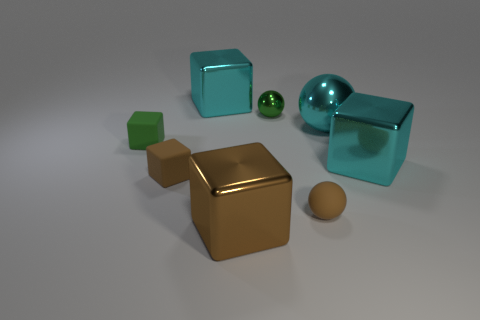Do the brown block that is on the right side of the tiny brown matte cube and the small green block have the same material?
Your response must be concise. No. There is a small sphere that is made of the same material as the large ball; what color is it?
Offer a terse response. Green. Are there fewer big cyan cubes in front of the tiny brown rubber block than green metallic balls on the left side of the large brown metallic thing?
Your response must be concise. No. Do the metallic cube that is right of the large brown metal thing and the small rubber thing that is on the right side of the green sphere have the same color?
Your response must be concise. No. Are there any other brown blocks that have the same material as the large brown cube?
Provide a succinct answer. No. There is a matte object that is on the right side of the brown block that is in front of the small matte ball; what size is it?
Your answer should be compact. Small. Are there more balls than large cyan cubes?
Give a very brief answer. Yes. Do the cyan thing that is in front of the green block and the small brown ball have the same size?
Offer a terse response. No. What number of metallic objects are the same color as the large metallic ball?
Your answer should be very brief. 2. Is the brown metal thing the same shape as the small green metallic thing?
Give a very brief answer. No. 